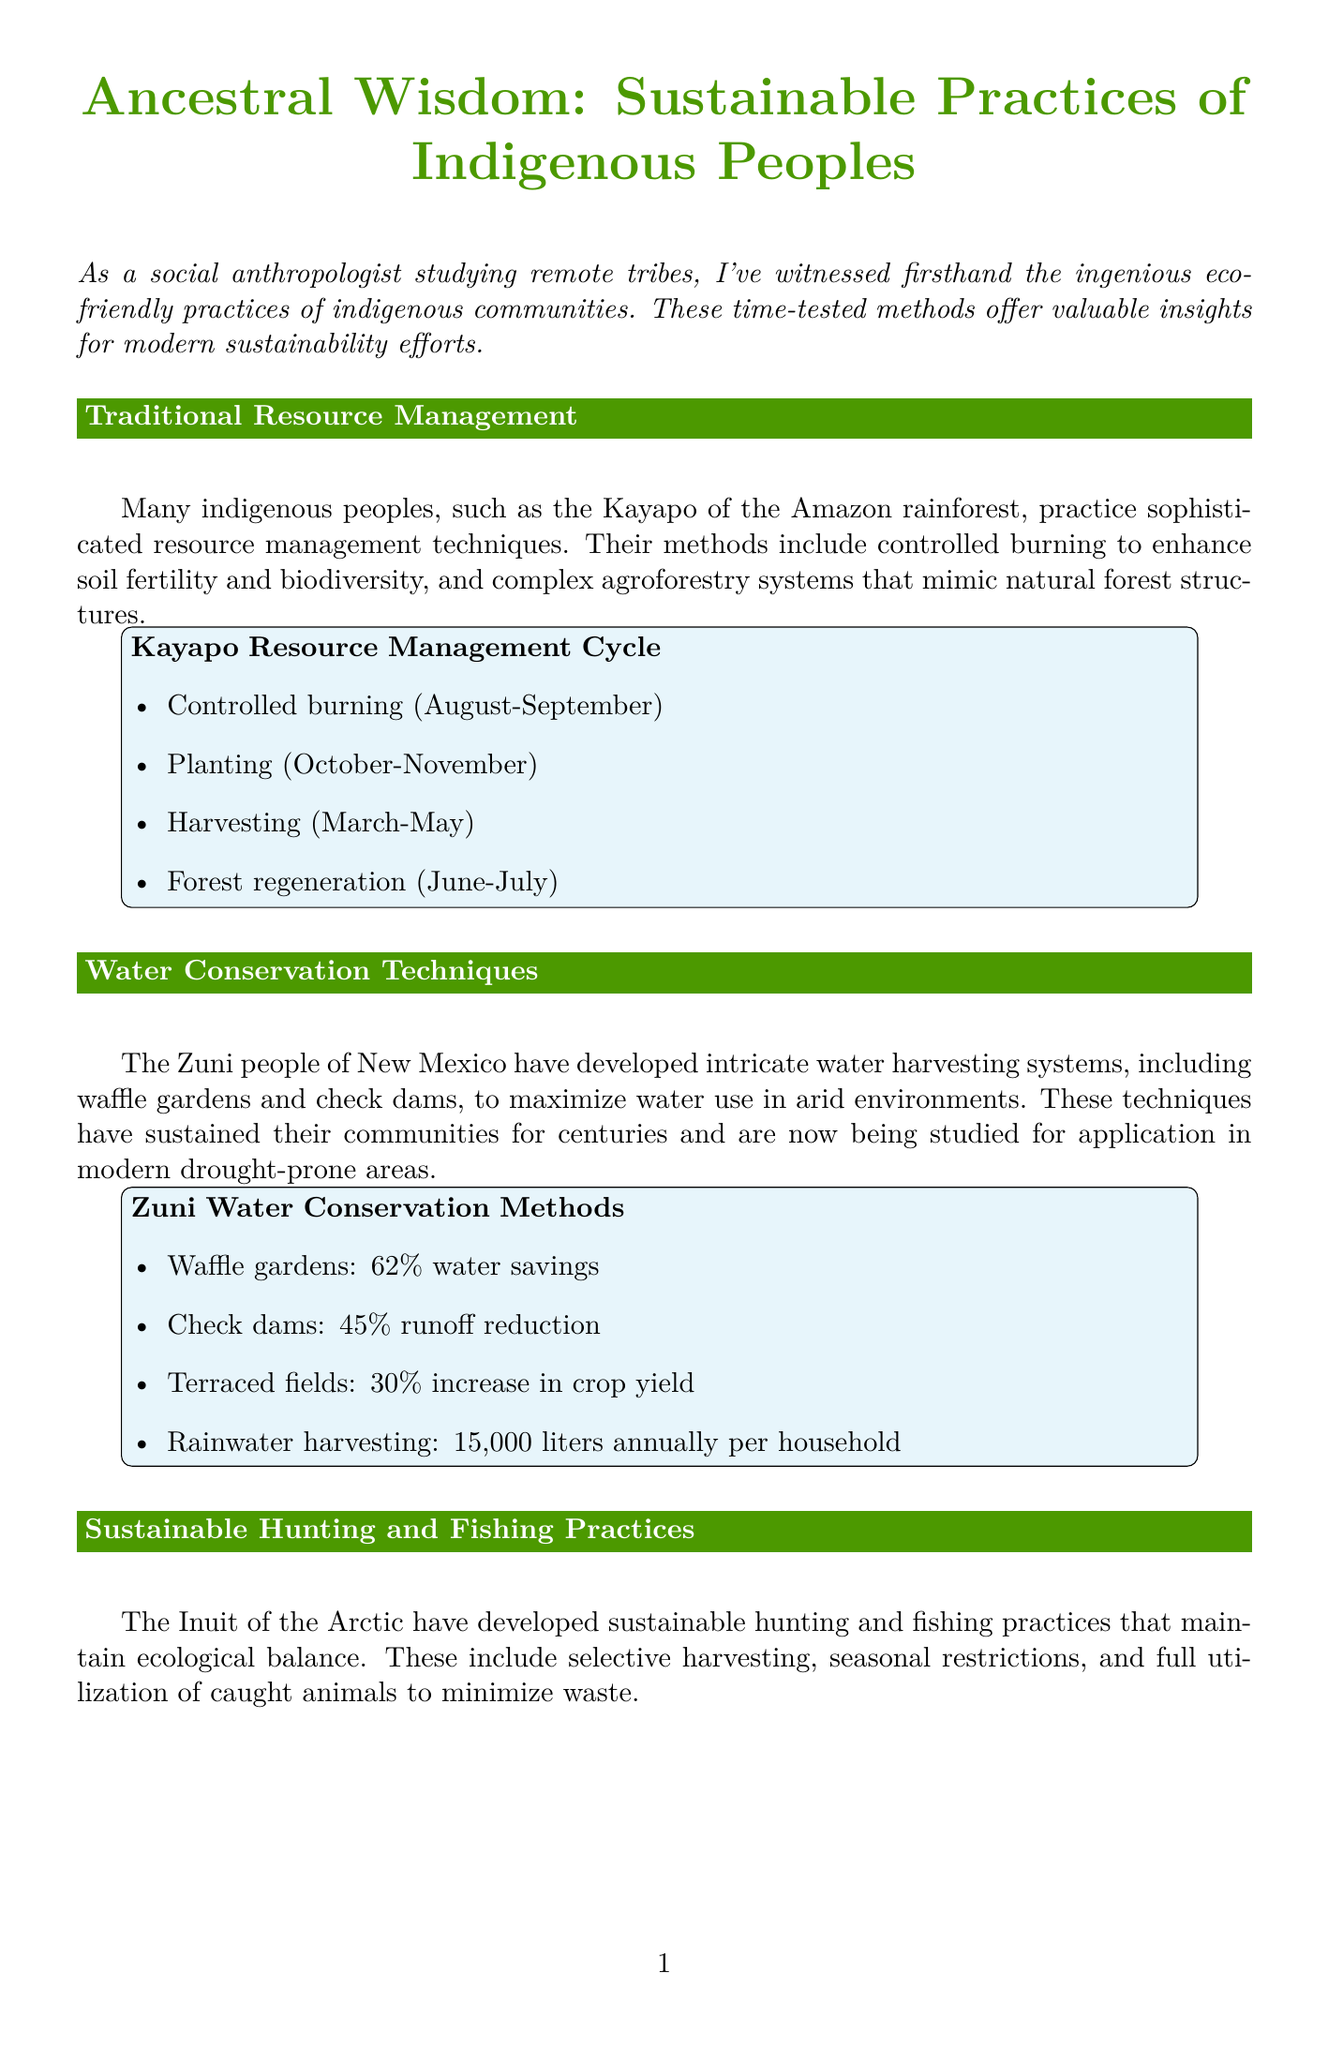What eco-friendly practice do the Kayapo use to enhance soil fertility? The Kayapo use controlled burning to enhance soil fertility, as mentioned in the section on Traditional Resource Management.
Answer: Controlled burning What percentage of water savings do waffle gardens provide? The document specifies that waffle gardens offer a 62% water savings in the section on Water Conservation Techniques.
Answer: 62% What is the title of the case study featured in the newsletter? The title of the case study is mentioned at the beginning of the section dedicated to it.
Answer: The Sápara: Guardians of Biodiversity How many plant species do the Sápara have knowledge of? The Sápara's intimate knowledge of over 1,300 plant species is highlighted in the case study section.
Answer: 1,300 What reduction in overfishing is reported for Inuit sustainable hunting practices? The impact of Inuit sustainable hunting includes a 25% reduction in overfishing, as outlined in the Sustainable Hunting and Fishing Practices section.
Answer: 25% What is the annual rainwater harvesting benefit per household for the Zuni people? The document states that rainwater harvesting leads to 15,000 liters annually per household in the section on Water Conservation Techniques.
Answer: 15,000 liters What innovative method do the Zuni use for water harvesting? The Zuni community utilizes a specific method mentioned in the Water Conservation Techniques section.
Answer: Waffle gardens What is the primary focus of Dr. Maya Thompson's research? Dr. Maya Thompson specializes in indigenous resource management, as described in the About the Author section.
Answer: Indigenous resource management 